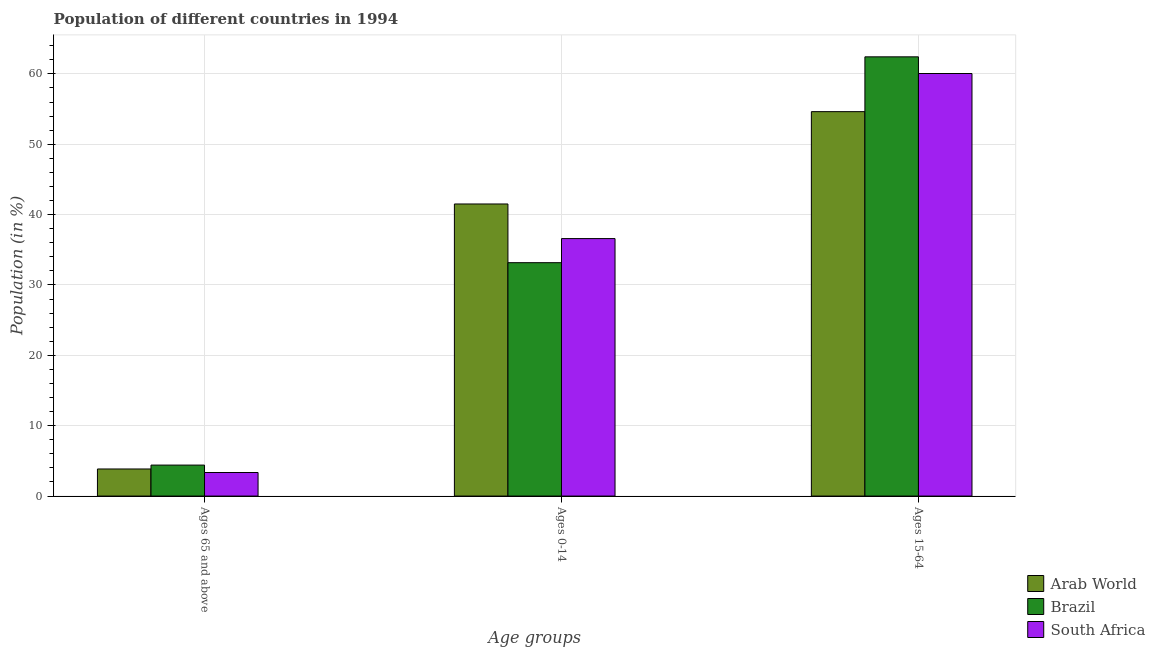How many groups of bars are there?
Keep it short and to the point. 3. How many bars are there on the 2nd tick from the left?
Give a very brief answer. 3. What is the label of the 3rd group of bars from the left?
Provide a short and direct response. Ages 15-64. What is the percentage of population within the age-group of 65 and above in South Africa?
Provide a short and direct response. 3.35. Across all countries, what is the maximum percentage of population within the age-group 0-14?
Your response must be concise. 41.51. Across all countries, what is the minimum percentage of population within the age-group 0-14?
Your response must be concise. 33.17. What is the total percentage of population within the age-group 15-64 in the graph?
Your response must be concise. 177.12. What is the difference between the percentage of population within the age-group 15-64 in South Africa and that in Arab World?
Your answer should be compact. 5.42. What is the difference between the percentage of population within the age-group 15-64 in Brazil and the percentage of population within the age-group 0-14 in South Africa?
Offer a terse response. 25.83. What is the average percentage of population within the age-group 15-64 per country?
Ensure brevity in your answer.  59.04. What is the difference between the percentage of population within the age-group of 65 and above and percentage of population within the age-group 0-14 in Arab World?
Offer a terse response. -37.66. In how many countries, is the percentage of population within the age-group of 65 and above greater than 30 %?
Keep it short and to the point. 0. What is the ratio of the percentage of population within the age-group 0-14 in Arab World to that in Brazil?
Provide a succinct answer. 1.25. Is the percentage of population within the age-group 15-64 in Brazil less than that in Arab World?
Provide a short and direct response. No. Is the difference between the percentage of population within the age-group 0-14 in Arab World and South Africa greater than the difference between the percentage of population within the age-group 15-64 in Arab World and South Africa?
Provide a succinct answer. Yes. What is the difference between the highest and the second highest percentage of population within the age-group of 65 and above?
Provide a succinct answer. 0.55. What is the difference between the highest and the lowest percentage of population within the age-group 0-14?
Your response must be concise. 8.34. In how many countries, is the percentage of population within the age-group 0-14 greater than the average percentage of population within the age-group 0-14 taken over all countries?
Your response must be concise. 1. What does the 1st bar from the left in Ages 65 and above represents?
Provide a succinct answer. Arab World. What does the 3rd bar from the right in Ages 15-64 represents?
Offer a very short reply. Arab World. Is it the case that in every country, the sum of the percentage of population within the age-group of 65 and above and percentage of population within the age-group 0-14 is greater than the percentage of population within the age-group 15-64?
Your answer should be compact. No. How many bars are there?
Provide a succinct answer. 9. How many countries are there in the graph?
Make the answer very short. 3. Are the values on the major ticks of Y-axis written in scientific E-notation?
Offer a terse response. No. Does the graph contain any zero values?
Offer a very short reply. No. Does the graph contain grids?
Provide a short and direct response. Yes. Where does the legend appear in the graph?
Your response must be concise. Bottom right. How are the legend labels stacked?
Offer a terse response. Vertical. What is the title of the graph?
Provide a succinct answer. Population of different countries in 1994. Does "Denmark" appear as one of the legend labels in the graph?
Give a very brief answer. No. What is the label or title of the X-axis?
Offer a terse response. Age groups. What is the Population (in %) in Arab World in Ages 65 and above?
Give a very brief answer. 3.85. What is the Population (in %) in Brazil in Ages 65 and above?
Make the answer very short. 4.4. What is the Population (in %) in South Africa in Ages 65 and above?
Ensure brevity in your answer.  3.35. What is the Population (in %) of Arab World in Ages 0-14?
Offer a terse response. 41.51. What is the Population (in %) in Brazil in Ages 0-14?
Your response must be concise. 33.17. What is the Population (in %) in South Africa in Ages 0-14?
Offer a very short reply. 36.59. What is the Population (in %) in Arab World in Ages 15-64?
Offer a terse response. 54.64. What is the Population (in %) in Brazil in Ages 15-64?
Your answer should be compact. 62.43. What is the Population (in %) of South Africa in Ages 15-64?
Ensure brevity in your answer.  60.06. Across all Age groups, what is the maximum Population (in %) of Arab World?
Provide a succinct answer. 54.64. Across all Age groups, what is the maximum Population (in %) of Brazil?
Provide a succinct answer. 62.43. Across all Age groups, what is the maximum Population (in %) of South Africa?
Make the answer very short. 60.06. Across all Age groups, what is the minimum Population (in %) in Arab World?
Offer a terse response. 3.85. Across all Age groups, what is the minimum Population (in %) of Brazil?
Provide a succinct answer. 4.4. Across all Age groups, what is the minimum Population (in %) in South Africa?
Make the answer very short. 3.35. What is the total Population (in %) in South Africa in the graph?
Your answer should be very brief. 100. What is the difference between the Population (in %) in Arab World in Ages 65 and above and that in Ages 0-14?
Offer a terse response. -37.66. What is the difference between the Population (in %) in Brazil in Ages 65 and above and that in Ages 0-14?
Give a very brief answer. -28.77. What is the difference between the Population (in %) of South Africa in Ages 65 and above and that in Ages 0-14?
Offer a very short reply. -33.25. What is the difference between the Population (in %) in Arab World in Ages 65 and above and that in Ages 15-64?
Ensure brevity in your answer.  -50.79. What is the difference between the Population (in %) in Brazil in Ages 65 and above and that in Ages 15-64?
Offer a terse response. -58.02. What is the difference between the Population (in %) in South Africa in Ages 65 and above and that in Ages 15-64?
Make the answer very short. -56.71. What is the difference between the Population (in %) of Arab World in Ages 0-14 and that in Ages 15-64?
Keep it short and to the point. -13.12. What is the difference between the Population (in %) in Brazil in Ages 0-14 and that in Ages 15-64?
Your response must be concise. -29.26. What is the difference between the Population (in %) of South Africa in Ages 0-14 and that in Ages 15-64?
Keep it short and to the point. -23.46. What is the difference between the Population (in %) in Arab World in Ages 65 and above and the Population (in %) in Brazil in Ages 0-14?
Provide a succinct answer. -29.32. What is the difference between the Population (in %) in Arab World in Ages 65 and above and the Population (in %) in South Africa in Ages 0-14?
Provide a succinct answer. -32.74. What is the difference between the Population (in %) of Brazil in Ages 65 and above and the Population (in %) of South Africa in Ages 0-14?
Your answer should be compact. -32.19. What is the difference between the Population (in %) in Arab World in Ages 65 and above and the Population (in %) in Brazil in Ages 15-64?
Offer a terse response. -58.58. What is the difference between the Population (in %) in Arab World in Ages 65 and above and the Population (in %) in South Africa in Ages 15-64?
Your answer should be compact. -56.21. What is the difference between the Population (in %) in Brazil in Ages 65 and above and the Population (in %) in South Africa in Ages 15-64?
Ensure brevity in your answer.  -55.65. What is the difference between the Population (in %) in Arab World in Ages 0-14 and the Population (in %) in Brazil in Ages 15-64?
Make the answer very short. -20.91. What is the difference between the Population (in %) in Arab World in Ages 0-14 and the Population (in %) in South Africa in Ages 15-64?
Make the answer very short. -18.54. What is the difference between the Population (in %) in Brazil in Ages 0-14 and the Population (in %) in South Africa in Ages 15-64?
Ensure brevity in your answer.  -26.89. What is the average Population (in %) in Arab World per Age groups?
Your answer should be compact. 33.33. What is the average Population (in %) in Brazil per Age groups?
Your response must be concise. 33.33. What is the average Population (in %) of South Africa per Age groups?
Provide a short and direct response. 33.33. What is the difference between the Population (in %) in Arab World and Population (in %) in Brazil in Ages 65 and above?
Ensure brevity in your answer.  -0.55. What is the difference between the Population (in %) of Arab World and Population (in %) of South Africa in Ages 65 and above?
Provide a succinct answer. 0.5. What is the difference between the Population (in %) of Brazil and Population (in %) of South Africa in Ages 65 and above?
Your response must be concise. 1.05. What is the difference between the Population (in %) in Arab World and Population (in %) in Brazil in Ages 0-14?
Keep it short and to the point. 8.34. What is the difference between the Population (in %) of Arab World and Population (in %) of South Africa in Ages 0-14?
Your answer should be very brief. 4.92. What is the difference between the Population (in %) of Brazil and Population (in %) of South Africa in Ages 0-14?
Your answer should be compact. -3.42. What is the difference between the Population (in %) in Arab World and Population (in %) in Brazil in Ages 15-64?
Offer a very short reply. -7.79. What is the difference between the Population (in %) of Arab World and Population (in %) of South Africa in Ages 15-64?
Offer a terse response. -5.42. What is the difference between the Population (in %) of Brazil and Population (in %) of South Africa in Ages 15-64?
Ensure brevity in your answer.  2.37. What is the ratio of the Population (in %) of Arab World in Ages 65 and above to that in Ages 0-14?
Your answer should be compact. 0.09. What is the ratio of the Population (in %) of Brazil in Ages 65 and above to that in Ages 0-14?
Your answer should be very brief. 0.13. What is the ratio of the Population (in %) in South Africa in Ages 65 and above to that in Ages 0-14?
Ensure brevity in your answer.  0.09. What is the ratio of the Population (in %) in Arab World in Ages 65 and above to that in Ages 15-64?
Give a very brief answer. 0.07. What is the ratio of the Population (in %) of Brazil in Ages 65 and above to that in Ages 15-64?
Offer a very short reply. 0.07. What is the ratio of the Population (in %) in South Africa in Ages 65 and above to that in Ages 15-64?
Your response must be concise. 0.06. What is the ratio of the Population (in %) of Arab World in Ages 0-14 to that in Ages 15-64?
Ensure brevity in your answer.  0.76. What is the ratio of the Population (in %) in Brazil in Ages 0-14 to that in Ages 15-64?
Your response must be concise. 0.53. What is the ratio of the Population (in %) in South Africa in Ages 0-14 to that in Ages 15-64?
Your answer should be very brief. 0.61. What is the difference between the highest and the second highest Population (in %) of Arab World?
Provide a short and direct response. 13.12. What is the difference between the highest and the second highest Population (in %) in Brazil?
Your answer should be compact. 29.26. What is the difference between the highest and the second highest Population (in %) in South Africa?
Your answer should be very brief. 23.46. What is the difference between the highest and the lowest Population (in %) of Arab World?
Keep it short and to the point. 50.79. What is the difference between the highest and the lowest Population (in %) in Brazil?
Provide a succinct answer. 58.02. What is the difference between the highest and the lowest Population (in %) of South Africa?
Provide a short and direct response. 56.71. 